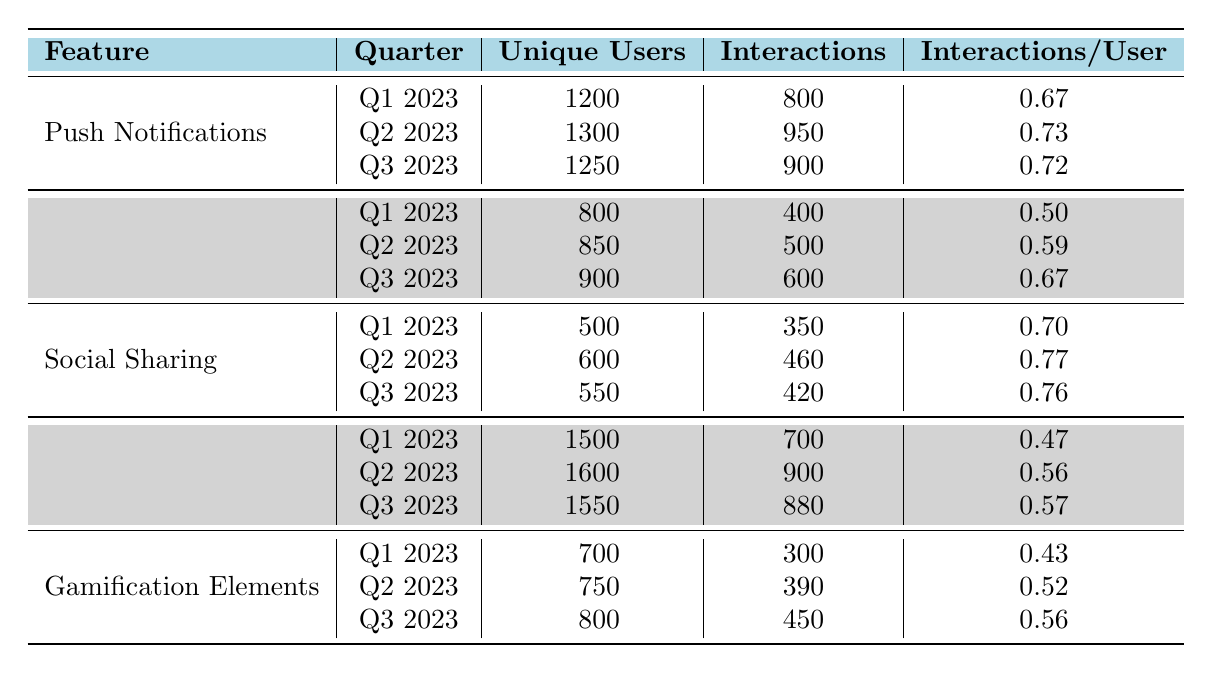What is the total number of unique users for Push Notifications across all quarters? The unique users for Push Notifications are 1200 in Q1, 1300 in Q2, and 1250 in Q3. Adding these together gives us 1200 + 1300 + 1250 = 3750.
Answer: 3750 Which feature had the highest interactions in Q2 2023? In Q2 2023, the interactions for each feature are as follows: Push Notifications - 950, In-app Messaging - 500, Social Sharing - 460, User Profiles - 900, Gamification Elements - 390. The highest is Push Notifications with 950 interactions.
Answer: Push Notifications What is the average interactions per user for User Profiles over the three quarters? The interactions per user for User Profiles are 0.47 in Q1, 0.56 in Q2, and 0.57 in Q3. To calculate the average, sum these values: 0.47 + 0.56 + 0.57 = 1.60. Dividing by 3 gives us 1.60 / 3 = 0.5333.
Answer: 0.53 Did the unique users for Gamification Elements increase every quarter? The unique users for Gamification Elements are 700 in Q1, 750 in Q2, and 800 in Q3. Since the numbers increased each quarter (700 < 750 < 800), the answer is yes.
Answer: Yes What was the total number of interactions for In-app Messaging over Q1 2023 to Q3 2023? The interactions for In-app Messaging are 400 in Q1, 500 in Q2, and 600 in Q3. Adding these gives 400 + 500 + 600 = 1500.
Answer: 1500 Which feature had the lowest interactions per user in Q1 2023? In Q1 2023, the interactions per user for each feature are: Push Notifications - 0.67, In-app Messaging - 0.50, Social Sharing - 0.70, User Profiles - 0.47, Gamification Elements - 0.43. The lowest is Gamification Elements with 0.43.
Answer: Gamification Elements What was the percentage increase in unique users for Social Sharing from Q1 2023 to Q2 2023? Social Sharing had 500 unique users in Q1 and 600 in Q2. The increase is 600 - 500 = 100. The percentage increase is (100/500) * 100 = 20%.
Answer: 20% Which feature had the highest average interactions per user over all quarters? The interactions per user for each feature across the three quarters are: Push Notifications: (0.67 + 0.73 + 0.72)/3 = 0.72; In-app Messaging: (0.50 + 0.59 + 0.67)/3 = 0.592; Social Sharing: (0.70 + 0.77 + 0.76)/3 = 0.7433; User Profiles: (0.47 + 0.56 + 0.57)/3 = 0.5333; Gamification Elements: (0.43 + 0.52 + 0.56)/3 = 0.510. The highest average is for Social Sharing with 0.7433.
Answer: Social Sharing How many total interactions were recorded for all features in Q3 2023? The interactions in Q3 2023 for each feature are: Push Notifications - 900, In-app Messaging - 600, Social Sharing - 420, User Profiles - 880, Gamification Elements - 450. The total is 900 + 600 + 420 + 880 + 450 = 3250.
Answer: 3250 What is the difference in unique users for User Profiles between Q1 and Q3 2023? Unique users for User Profiles in Q1 are 1500 and in Q3 are 1550. The difference is 1550 - 1500 = 50.
Answer: 50 